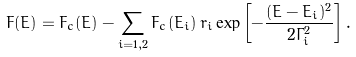<formula> <loc_0><loc_0><loc_500><loc_500>F ( E ) = F _ { c } ( E ) - \sum _ { i = 1 , 2 } F _ { c } ( E _ { i } ) \, r _ { i } \exp \left [ - \frac { ( E - E _ { i } ) ^ { 2 } } { 2 \Gamma _ { i } ^ { 2 } } \right ] .</formula> 